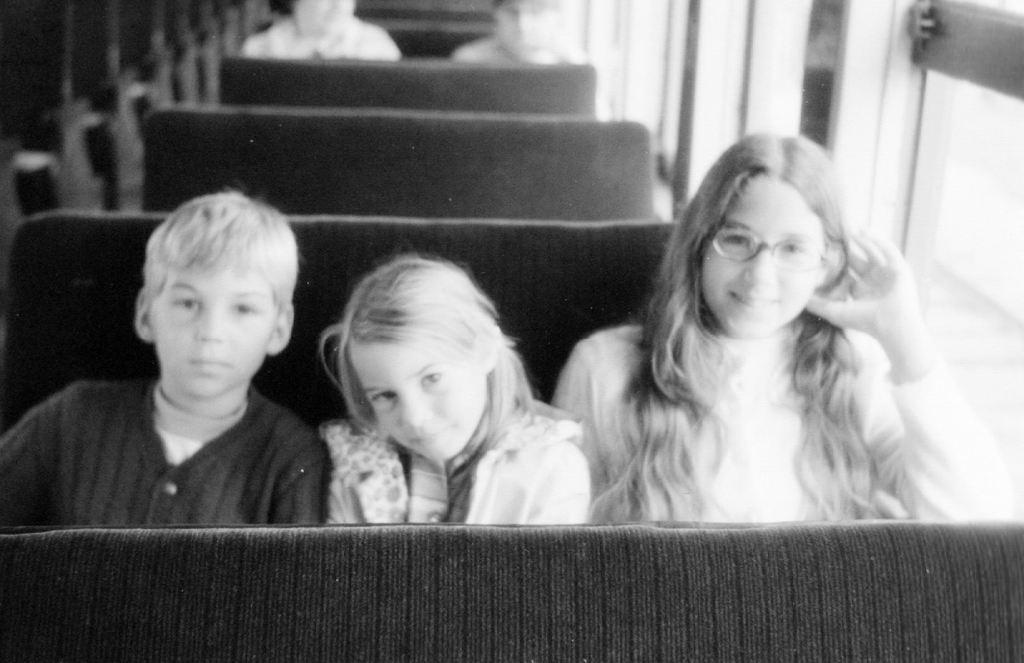How would you summarize this image in a sentence or two? Here in the front we can see three children sitting on a seat over there and we can say this is a bus from its inner view and behind them also we can see people sitting on seats over there. 